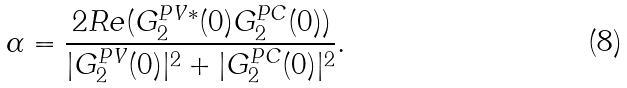<formula> <loc_0><loc_0><loc_500><loc_500>\alpha = \frac { 2 R e ( G _ { 2 } ^ { P V * } ( 0 ) G _ { 2 } ^ { P C } ( 0 ) ) } { | G _ { 2 } ^ { P V } ( 0 ) | ^ { 2 } + | G _ { 2 } ^ { P C } ( 0 ) | ^ { 2 } } .</formula> 